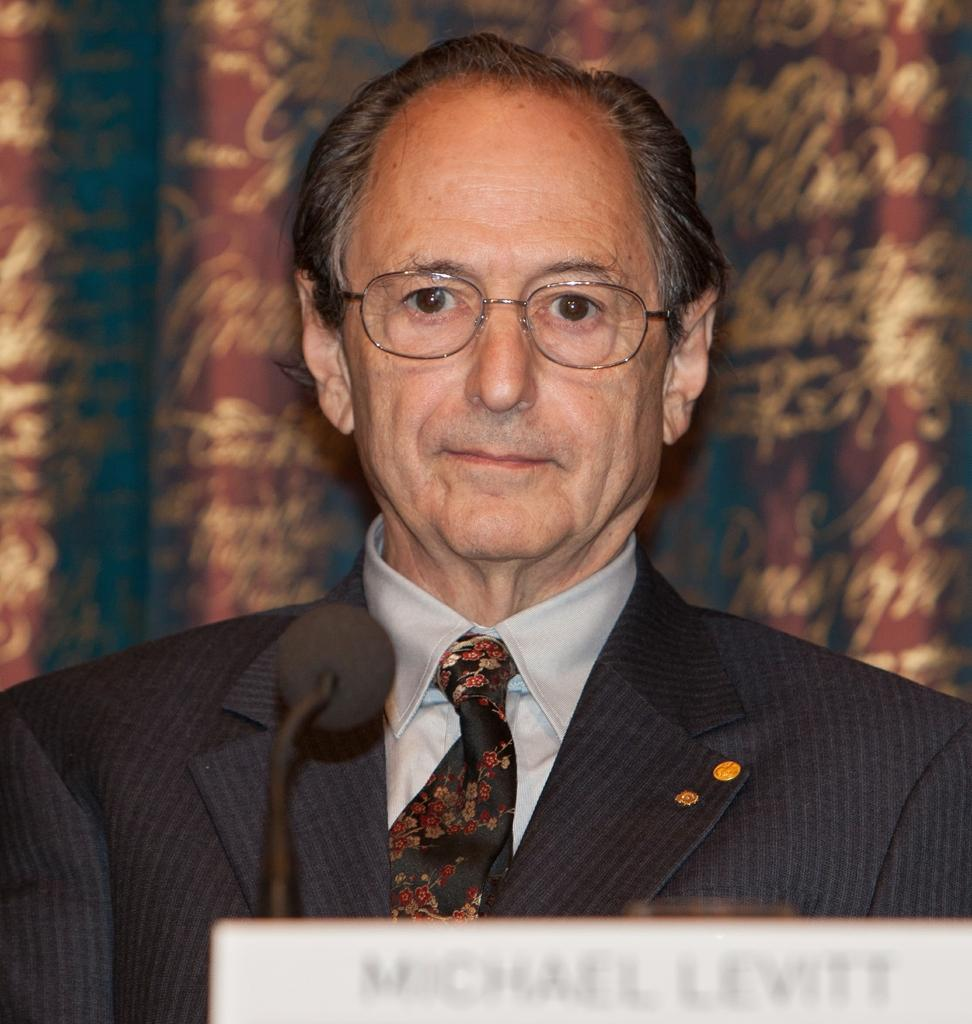What is the main subject of the image? There is a person in the image. What is the person wearing? The person is wearing a black color suit. What is the person doing in the image? The person is standing in front of a microphone. What accessory is the person wearing? The person is wearing spectacles. What type of furniture is the person using to teach in the image? There is no furniture present in the image, and the person is not teaching. 